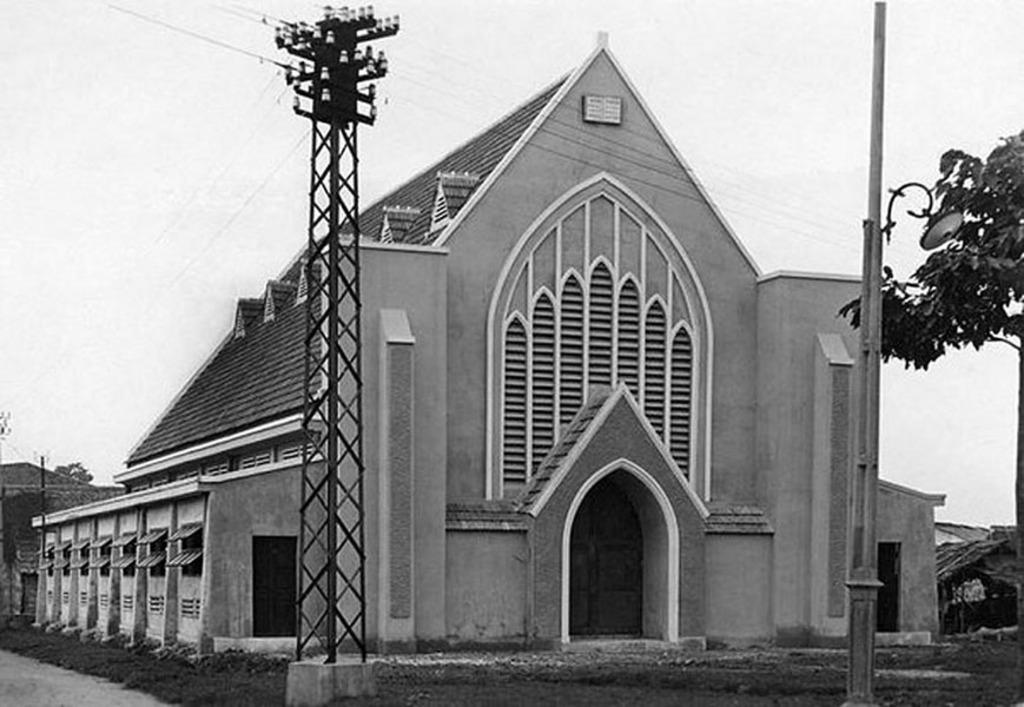In one or two sentences, can you explain what this image depicts? This is a black and white picture. In this picture we can see the sky, house, windows, door. On the right side of the picture we can see a tree. We can see an electrical pole and other poles. 